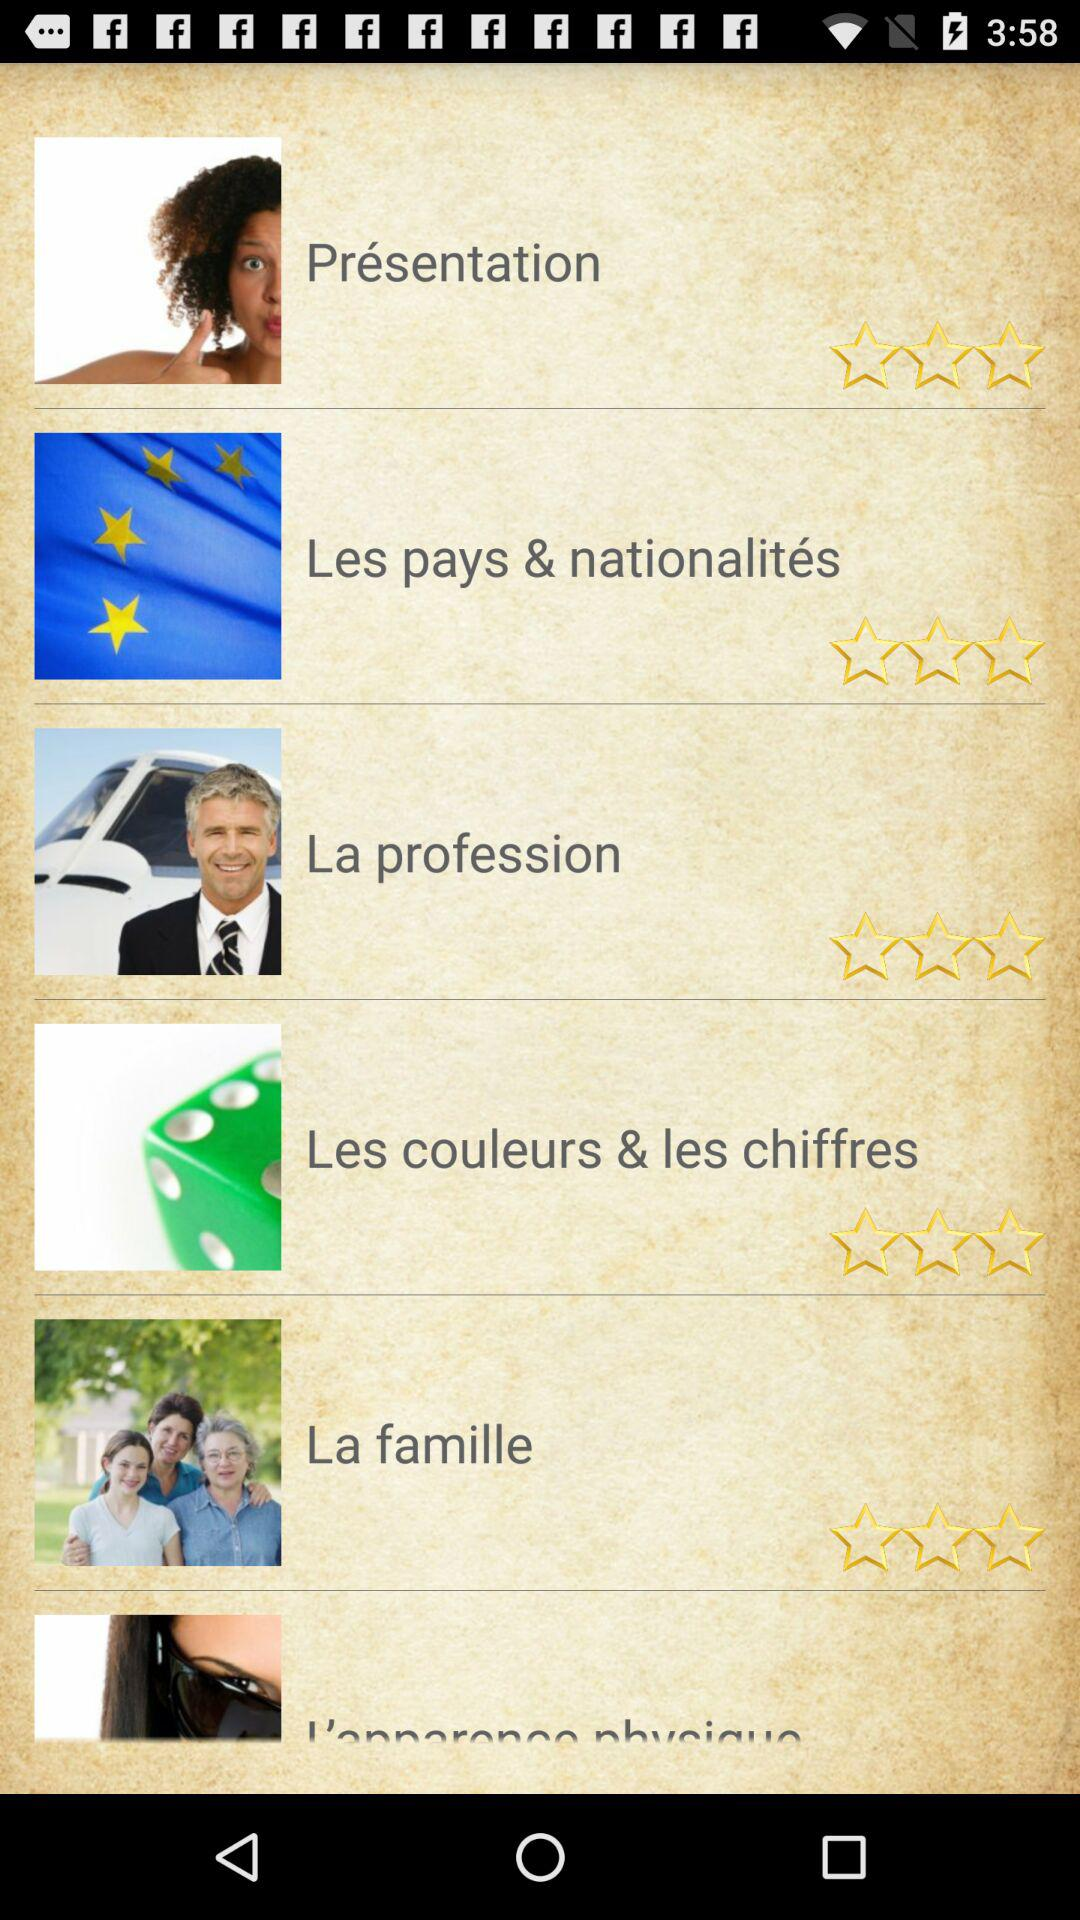How many topics are there?
Answer the question using a single word or phrase. 6 